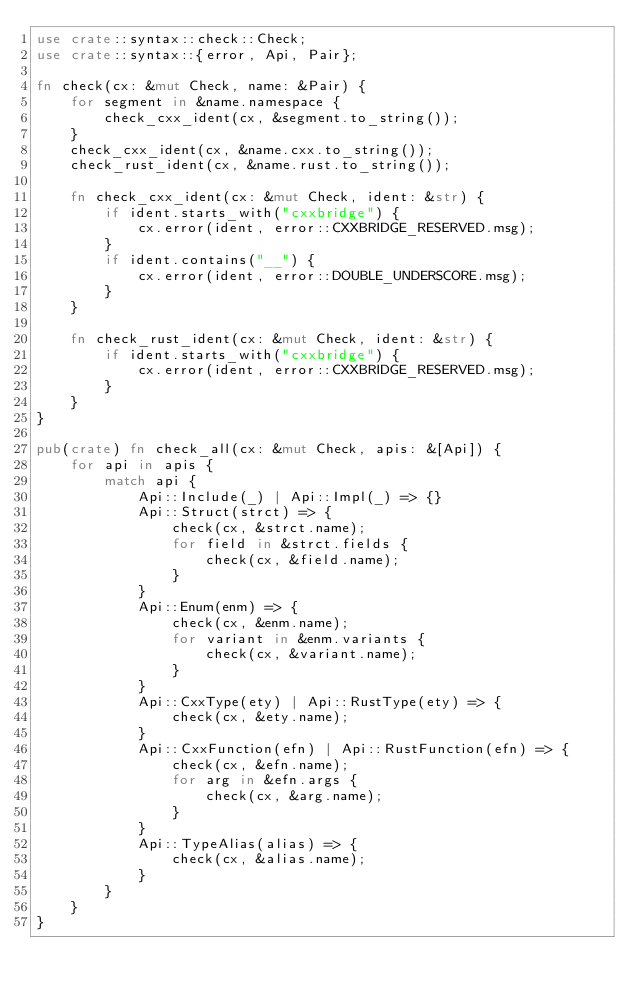Convert code to text. <code><loc_0><loc_0><loc_500><loc_500><_Rust_>use crate::syntax::check::Check;
use crate::syntax::{error, Api, Pair};

fn check(cx: &mut Check, name: &Pair) {
    for segment in &name.namespace {
        check_cxx_ident(cx, &segment.to_string());
    }
    check_cxx_ident(cx, &name.cxx.to_string());
    check_rust_ident(cx, &name.rust.to_string());

    fn check_cxx_ident(cx: &mut Check, ident: &str) {
        if ident.starts_with("cxxbridge") {
            cx.error(ident, error::CXXBRIDGE_RESERVED.msg);
        }
        if ident.contains("__") {
            cx.error(ident, error::DOUBLE_UNDERSCORE.msg);
        }
    }

    fn check_rust_ident(cx: &mut Check, ident: &str) {
        if ident.starts_with("cxxbridge") {
            cx.error(ident, error::CXXBRIDGE_RESERVED.msg);
        }
    }
}

pub(crate) fn check_all(cx: &mut Check, apis: &[Api]) {
    for api in apis {
        match api {
            Api::Include(_) | Api::Impl(_) => {}
            Api::Struct(strct) => {
                check(cx, &strct.name);
                for field in &strct.fields {
                    check(cx, &field.name);
                }
            }
            Api::Enum(enm) => {
                check(cx, &enm.name);
                for variant in &enm.variants {
                    check(cx, &variant.name);
                }
            }
            Api::CxxType(ety) | Api::RustType(ety) => {
                check(cx, &ety.name);
            }
            Api::CxxFunction(efn) | Api::RustFunction(efn) => {
                check(cx, &efn.name);
                for arg in &efn.args {
                    check(cx, &arg.name);
                }
            }
            Api::TypeAlias(alias) => {
                check(cx, &alias.name);
            }
        }
    }
}
</code> 